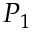<formula> <loc_0><loc_0><loc_500><loc_500>P _ { 1 }</formula> 